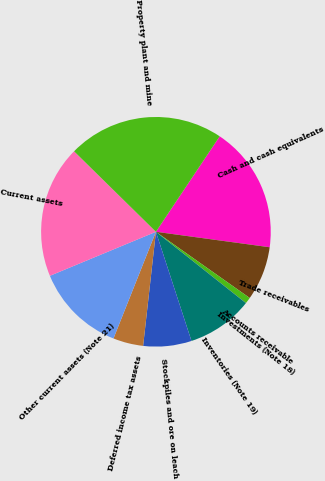Convert chart to OTSL. <chart><loc_0><loc_0><loc_500><loc_500><pie_chart><fcel>Cash and cash equivalents<fcel>Trade receivables<fcel>Accounts receivable<fcel>Investments (Note 18)<fcel>Inventories (Note 19)<fcel>Stockpiles and ore on leach<fcel>Deferred income tax assets<fcel>Other current assets (Note 21)<fcel>Current assets<fcel>Property plant and mine<nl><fcel>17.78%<fcel>7.63%<fcel>0.87%<fcel>0.02%<fcel>9.32%<fcel>6.79%<fcel>4.25%<fcel>12.71%<fcel>18.63%<fcel>22.01%<nl></chart> 